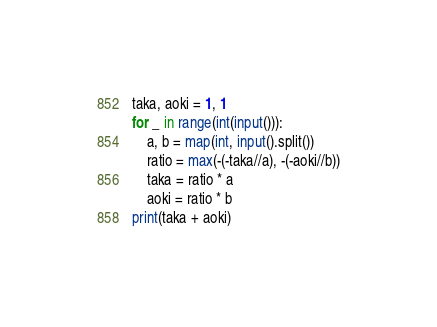Convert code to text. <code><loc_0><loc_0><loc_500><loc_500><_Python_>taka, aoki = 1, 1
for _ in range(int(input())):
    a, b = map(int, input().split())
    ratio = max(-(-taka//a), -(-aoki//b))
    taka = ratio * a
    aoki = ratio * b
print(taka + aoki)</code> 